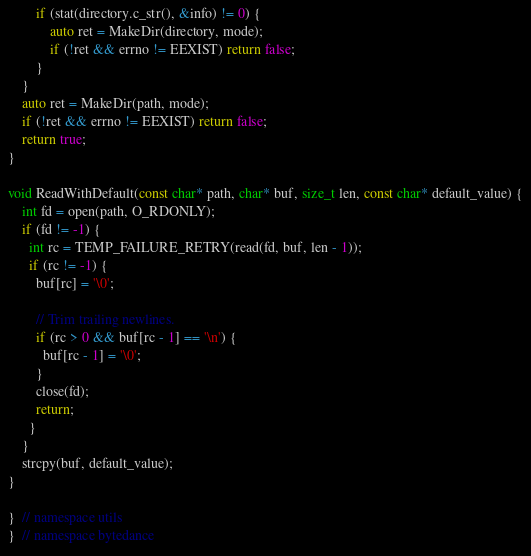<code> <loc_0><loc_0><loc_500><loc_500><_C++_>        if (stat(directory.c_str(), &info) != 0) {
            auto ret = MakeDir(directory, mode);
            if (!ret && errno != EEXIST) return false;
        }
    }
    auto ret = MakeDir(path, mode);
    if (!ret && errno != EEXIST) return false;
    return true;
}

void ReadWithDefault(const char* path, char* buf, size_t len, const char* default_value) {
    int fd = open(path, O_RDONLY);
    if (fd != -1) {
      int rc = TEMP_FAILURE_RETRY(read(fd, buf, len - 1));
      if (rc != -1) {
        buf[rc] = '\0';

        // Trim trailing newlines.
        if (rc > 0 && buf[rc - 1] == '\n') {
          buf[rc - 1] = '\0';
        }
        close(fd);
        return;
      }
    }
    strcpy(buf, default_value);
}

}  // namespace utils
}  // namespace bytedance
</code> 